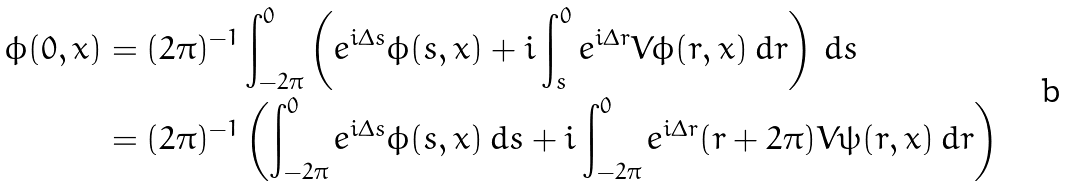Convert formula to latex. <formula><loc_0><loc_0><loc_500><loc_500>\phi ( 0 , x ) & = ( 2 \pi ) ^ { - 1 } \int _ { - 2 \pi } ^ { 0 } \left ( e ^ { i \Delta s } \phi ( s , x ) + i \int _ { s } ^ { 0 } e ^ { i \Delta r } V \phi ( r , x ) \, d r \right ) \, d s \\ & = ( 2 \pi ) ^ { - 1 } \left ( \int _ { - 2 \pi } ^ { 0 } e ^ { i \Delta s } \phi ( s , x ) \, d s + i \int _ { - 2 \pi } ^ { 0 } e ^ { i \Delta r } ( r + 2 \pi ) V \psi ( r , x ) \, d r \right )</formula> 